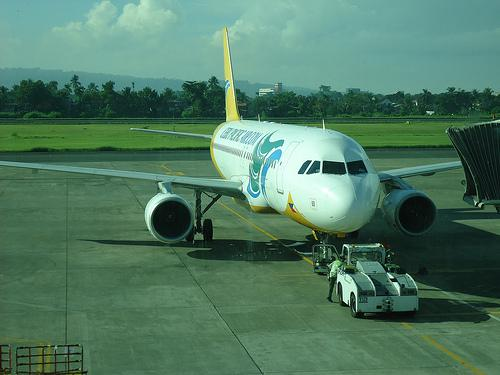Question: who drives the plane?
Choices:
A. Pilot.
B. Trainee.
C. The man.
D. The woman.
Answer with the letter. Answer: A Question: what is the color of tyre?
Choices:
A. White.
B. Red.
C. Blue.
D. Black.
Answer with the letter. Answer: D Question: what is the color of the tree?
Choices:
A. Yellow.
B. Green.
C. Red.
D. Brown.
Answer with the letter. Answer: B Question: what is the color of the cloud?
Choices:
A. Black.
B. White.
C. Gray.
D. Steel.
Answer with the letter. Answer: B 